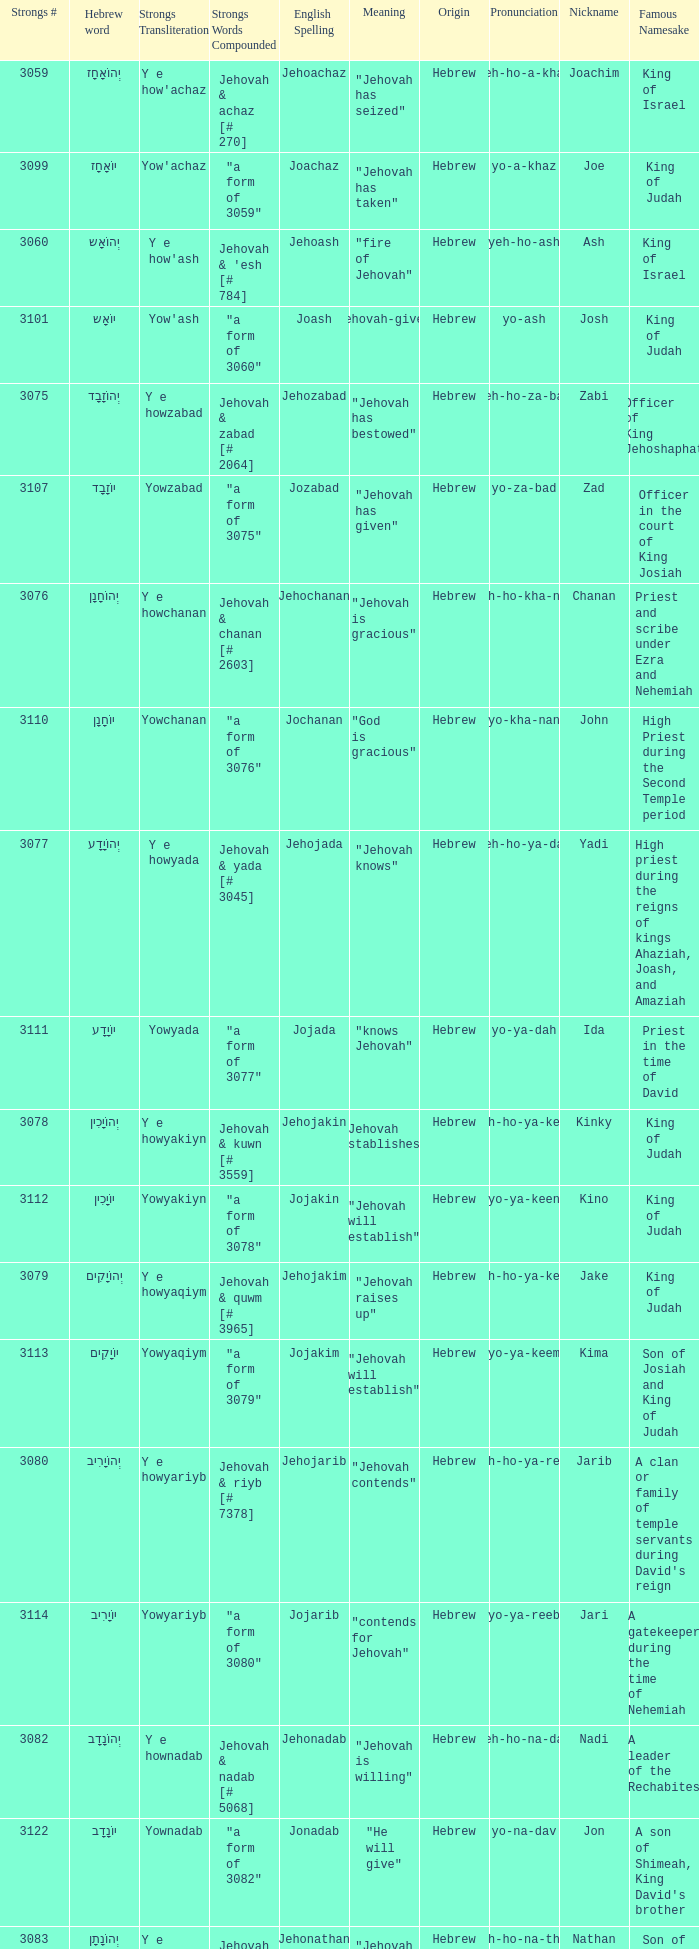What is the english spelling of the word that has the strongs trasliteration of y e howram? Jehoram. 